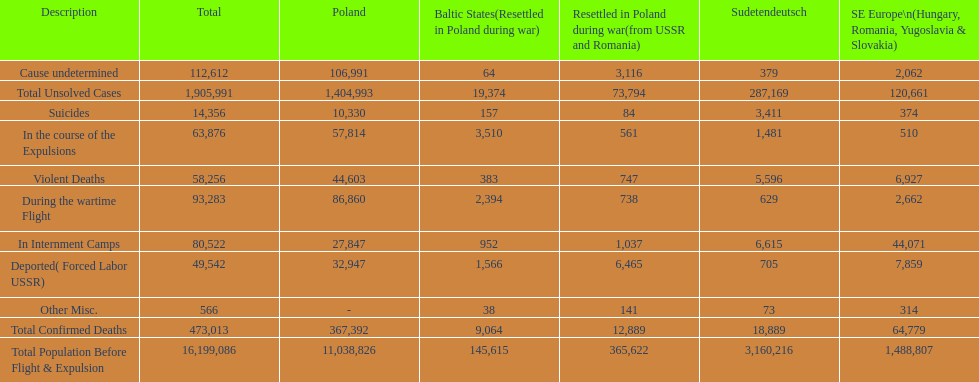Did any location have no violent deaths? No. 